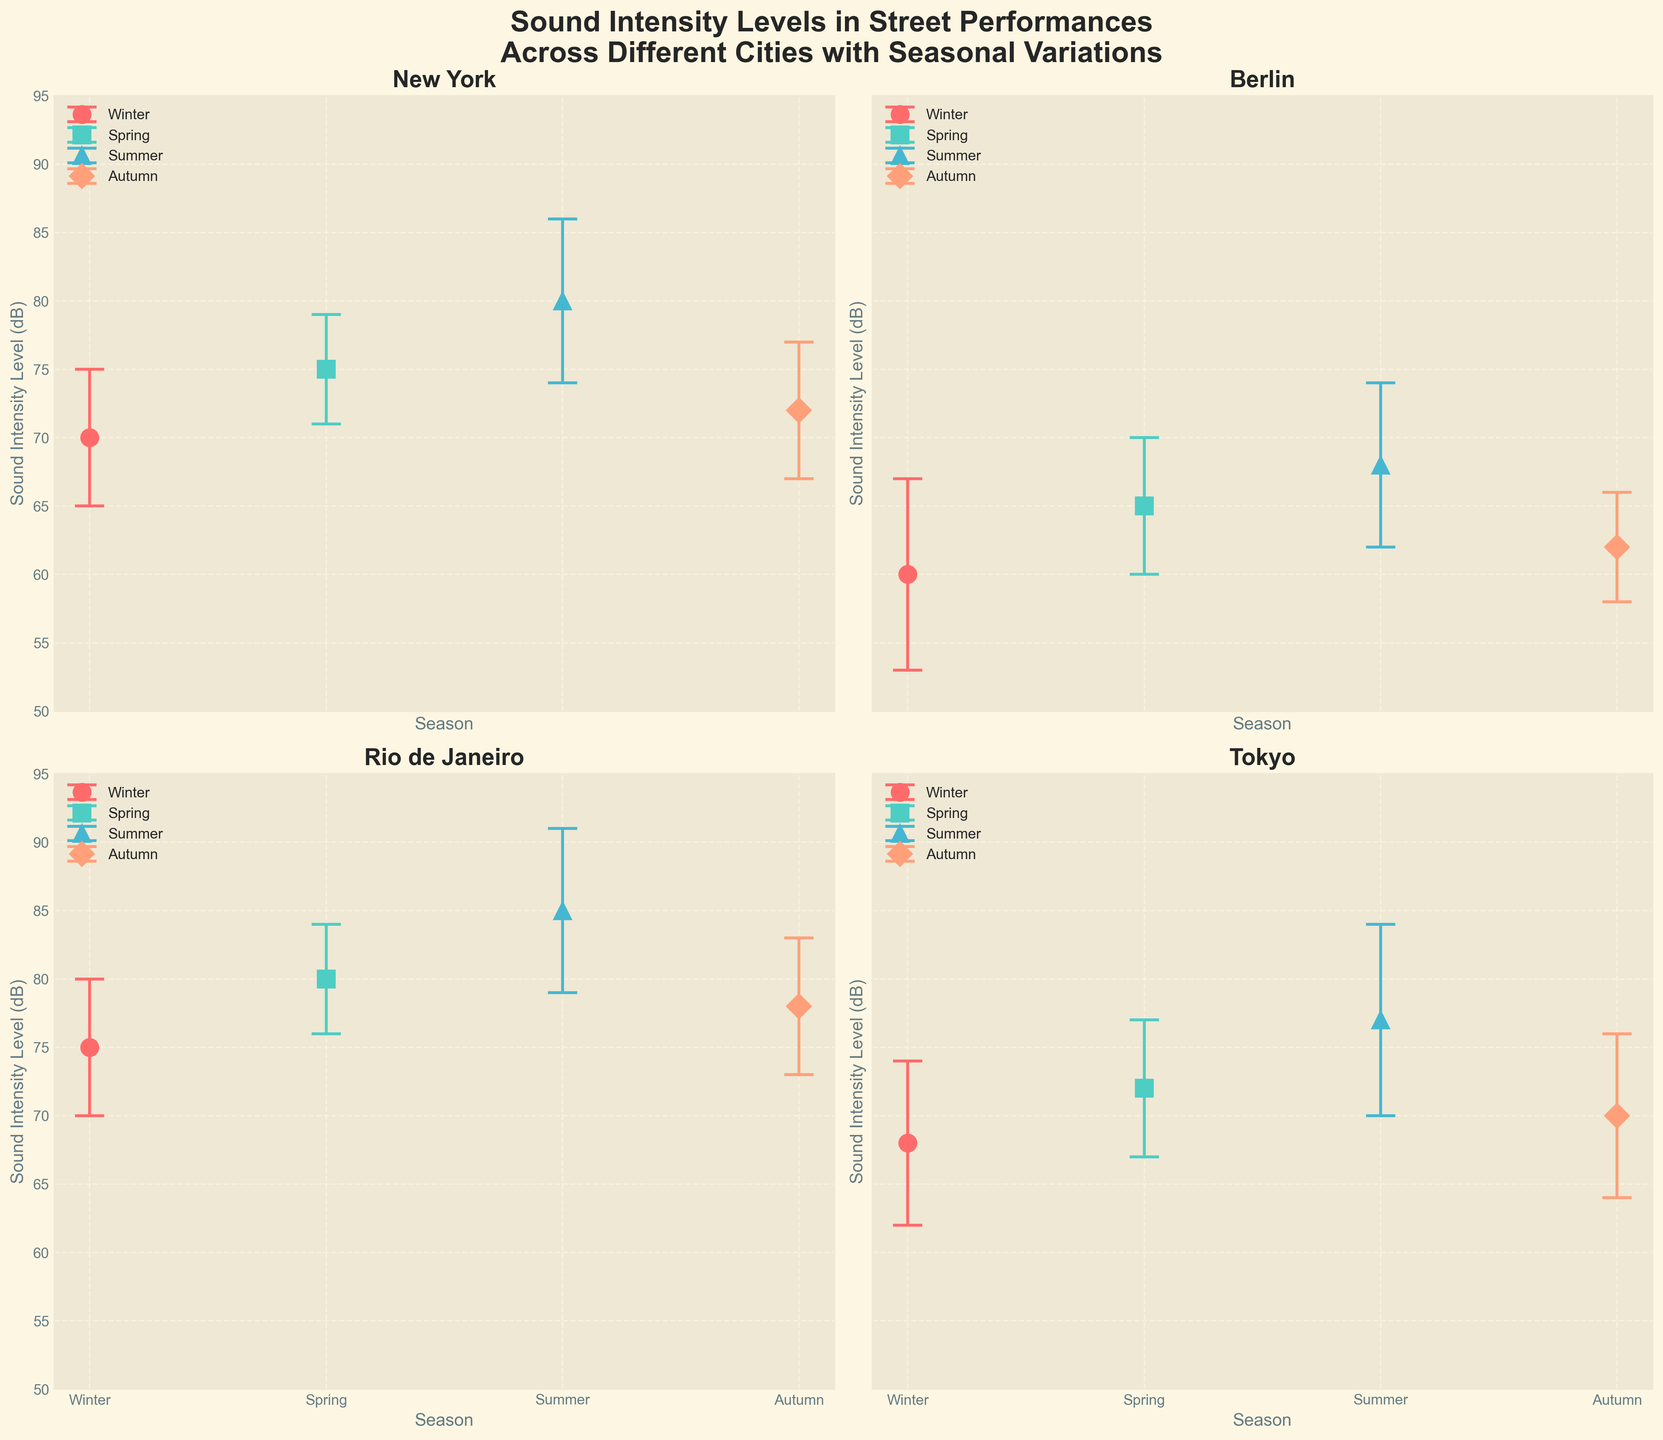What is the title of the figure? The title is located at the top of the figure and summarizes its main topic. It states: "Sound Intensity Levels in Street Performances Across Different Cities with Seasonal Variations".
Answer: Sound Intensity Levels in Street Performances Across Different Cities with Seasonal Variations Which city has the highest average sound intensity level in summer? Scan through each subplot, specifically the data points for the summer season. Rio de Janeiro is shown to have the highest average sound intensity level at 85 dB during summer.
Answer: Rio de Janeiro Which season has the lowest average sound intensity level in Berlin? Refer to the subplot with Berlin's data. Compare the mean intensity levels across all seasons. Winter shows the lowest average intensity level at 60 dB.
Answer: Winter What is the range of sound intensity levels in Tokyo during different seasons? Locate the subplot for Tokyo. Identify the maximum and minimum mean sound intensity levels across all seasons. Summer has the highest at 77 dB and Winter the lowest at 68 dB, giving a range of 77 - 68 = 9 dB.
Answer: 9 dB In Rio de Janeiro, what is the difference in average sound intensity level between spring and autumn? Refer to Rio de Janeiro's subplot and compare the values for spring (80 dB) and autumn (78 dB). The difference is calculated as 80 - 78 = 2 dB.
Answer: 2 dB Which city shows the most variation in sound intensity levels during the winter season? Examine the error bars for winter across all cities. Berlin has the largest standard deviation of 7 dB, indicating the most variation.
Answer: Berlin Does New York's sound intensity level increase from winter to summer? Check New York’s data points for winter and summer. Winter has 70 dB, and summer has 80 dB, illustrating an increase.
Answer: Yes Which season in Tokyo has the largest error margin in sound intensity levels? Look at the error bars in Tokyo’s subplot. Summer has the largest error margin of 7 dB.
Answer: Summer If the sound intensity level for New York in autumn increased by 3 dB, what would the new value be? The current autumn intensity level in New York is 72 dB. Adding 3 dB gives 72 + 3 = 75 dB.
Answer: 75 dB 